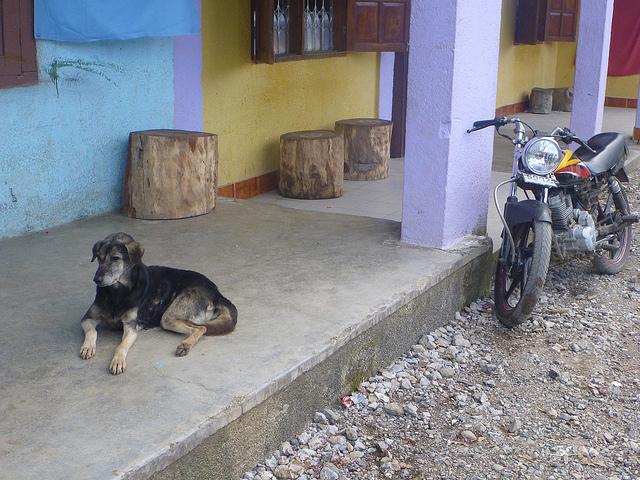Is this dog asleep?
Short answer required. No. Do you see a motorcycle?
Answer briefly. Yes. What is laying on the cement?
Short answer required. Dog. 